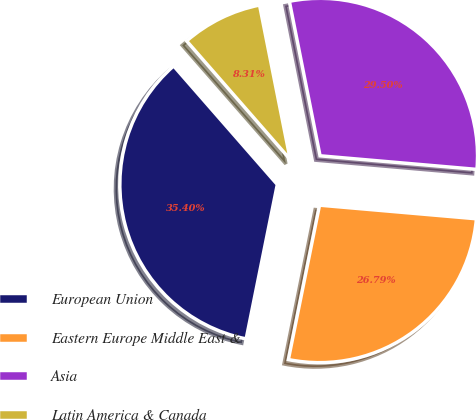Convert chart to OTSL. <chart><loc_0><loc_0><loc_500><loc_500><pie_chart><fcel>European Union<fcel>Eastern Europe Middle East &<fcel>Asia<fcel>Latin America & Canada<nl><fcel>35.4%<fcel>26.79%<fcel>29.5%<fcel>8.31%<nl></chart> 